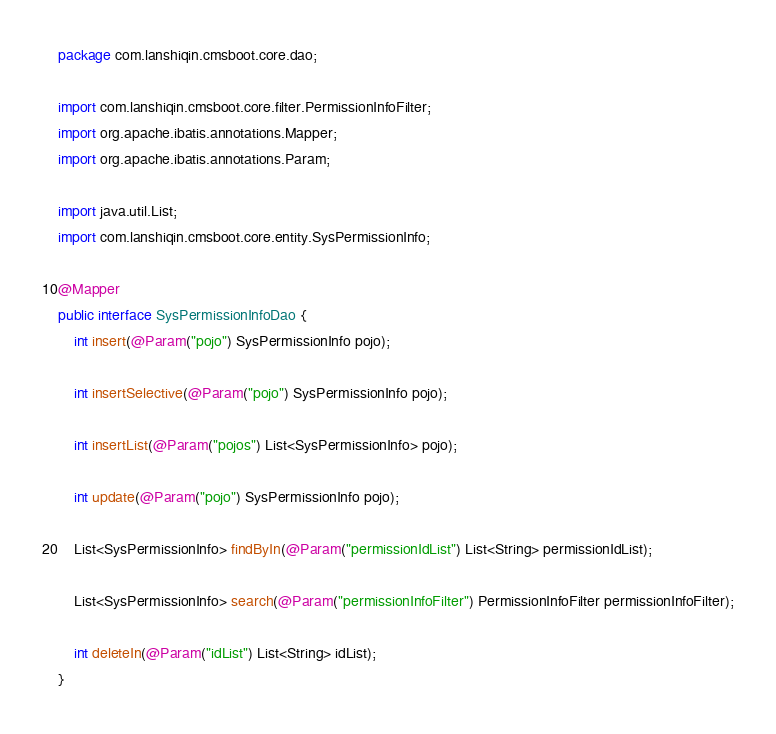Convert code to text. <code><loc_0><loc_0><loc_500><loc_500><_Java_>package com.lanshiqin.cmsboot.core.dao;

import com.lanshiqin.cmsboot.core.filter.PermissionInfoFilter;
import org.apache.ibatis.annotations.Mapper;
import org.apache.ibatis.annotations.Param;

import java.util.List;
import com.lanshiqin.cmsboot.core.entity.SysPermissionInfo;

@Mapper
public interface SysPermissionInfoDao {
    int insert(@Param("pojo") SysPermissionInfo pojo);

    int insertSelective(@Param("pojo") SysPermissionInfo pojo);

    int insertList(@Param("pojos") List<SysPermissionInfo> pojo);

    int update(@Param("pojo") SysPermissionInfo pojo);

    List<SysPermissionInfo> findByIn(@Param("permissionIdList") List<String> permissionIdList);

    List<SysPermissionInfo> search(@Param("permissionInfoFilter") PermissionInfoFilter permissionInfoFilter);

    int deleteIn(@Param("idList") List<String> idList);
}
</code> 